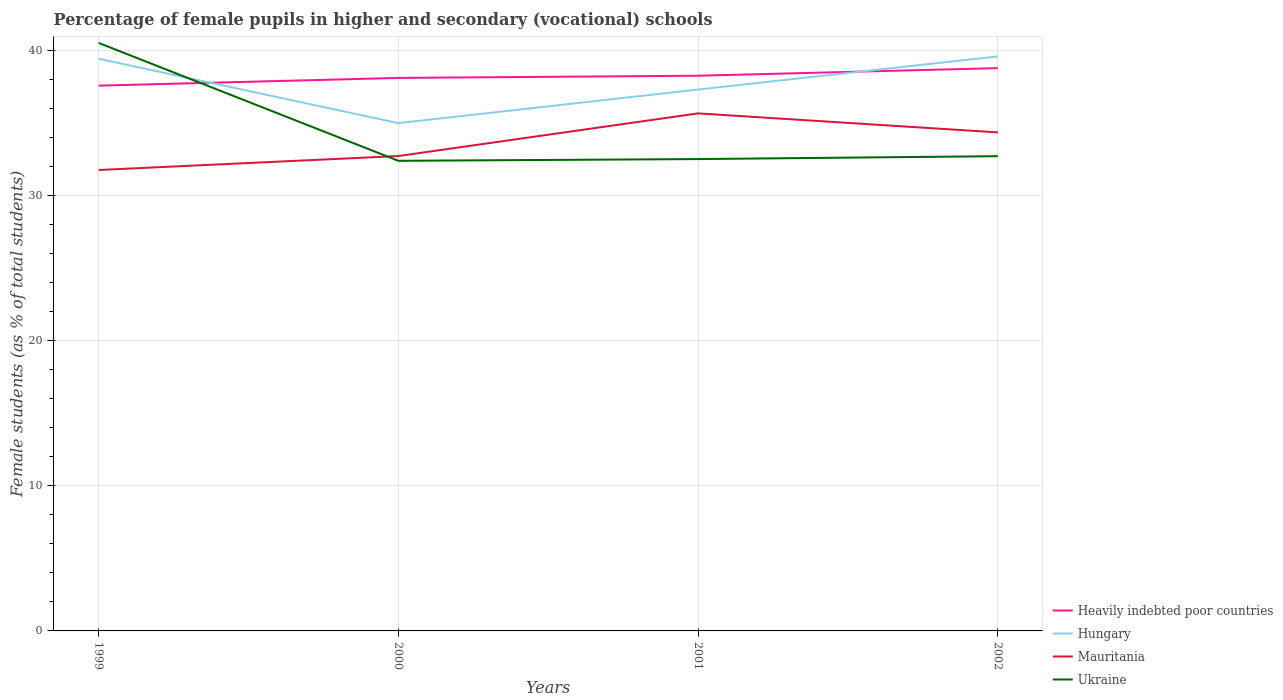How many different coloured lines are there?
Give a very brief answer. 4. Does the line corresponding to Mauritania intersect with the line corresponding to Hungary?
Offer a terse response. No. Across all years, what is the maximum percentage of female pupils in higher and secondary schools in Heavily indebted poor countries?
Make the answer very short. 37.56. What is the total percentage of female pupils in higher and secondary schools in Heavily indebted poor countries in the graph?
Your answer should be compact. -0.15. What is the difference between the highest and the second highest percentage of female pupils in higher and secondary schools in Mauritania?
Make the answer very short. 3.9. What is the difference between two consecutive major ticks on the Y-axis?
Make the answer very short. 10. Are the values on the major ticks of Y-axis written in scientific E-notation?
Your answer should be compact. No. Does the graph contain grids?
Ensure brevity in your answer.  Yes. Where does the legend appear in the graph?
Ensure brevity in your answer.  Bottom right. What is the title of the graph?
Provide a succinct answer. Percentage of female pupils in higher and secondary (vocational) schools. Does "Channel Islands" appear as one of the legend labels in the graph?
Keep it short and to the point. No. What is the label or title of the Y-axis?
Provide a succinct answer. Female students (as % of total students). What is the Female students (as % of total students) in Heavily indebted poor countries in 1999?
Provide a succinct answer. 37.56. What is the Female students (as % of total students) in Hungary in 1999?
Offer a very short reply. 39.41. What is the Female students (as % of total students) of Mauritania in 1999?
Offer a terse response. 31.75. What is the Female students (as % of total students) in Ukraine in 1999?
Your response must be concise. 40.5. What is the Female students (as % of total students) of Heavily indebted poor countries in 2000?
Provide a short and direct response. 38.09. What is the Female students (as % of total students) in Hungary in 2000?
Provide a short and direct response. 34.98. What is the Female students (as % of total students) in Mauritania in 2000?
Ensure brevity in your answer.  32.71. What is the Female students (as % of total students) in Ukraine in 2000?
Offer a terse response. 32.38. What is the Female students (as % of total students) in Heavily indebted poor countries in 2001?
Keep it short and to the point. 38.24. What is the Female students (as % of total students) of Hungary in 2001?
Make the answer very short. 37.29. What is the Female students (as % of total students) of Mauritania in 2001?
Keep it short and to the point. 35.65. What is the Female students (as % of total students) in Ukraine in 2001?
Ensure brevity in your answer.  32.5. What is the Female students (as % of total students) of Heavily indebted poor countries in 2002?
Your answer should be very brief. 38.77. What is the Female students (as % of total students) of Hungary in 2002?
Offer a terse response. 39.57. What is the Female students (as % of total students) of Mauritania in 2002?
Make the answer very short. 34.34. What is the Female students (as % of total students) in Ukraine in 2002?
Keep it short and to the point. 32.7. Across all years, what is the maximum Female students (as % of total students) in Heavily indebted poor countries?
Provide a succinct answer. 38.77. Across all years, what is the maximum Female students (as % of total students) of Hungary?
Your response must be concise. 39.57. Across all years, what is the maximum Female students (as % of total students) in Mauritania?
Offer a terse response. 35.65. Across all years, what is the maximum Female students (as % of total students) of Ukraine?
Your response must be concise. 40.5. Across all years, what is the minimum Female students (as % of total students) of Heavily indebted poor countries?
Your answer should be very brief. 37.56. Across all years, what is the minimum Female students (as % of total students) of Hungary?
Keep it short and to the point. 34.98. Across all years, what is the minimum Female students (as % of total students) of Mauritania?
Offer a terse response. 31.75. Across all years, what is the minimum Female students (as % of total students) of Ukraine?
Provide a short and direct response. 32.38. What is the total Female students (as % of total students) of Heavily indebted poor countries in the graph?
Offer a terse response. 152.65. What is the total Female students (as % of total students) in Hungary in the graph?
Ensure brevity in your answer.  151.25. What is the total Female students (as % of total students) in Mauritania in the graph?
Your answer should be compact. 134.44. What is the total Female students (as % of total students) in Ukraine in the graph?
Keep it short and to the point. 138.08. What is the difference between the Female students (as % of total students) in Heavily indebted poor countries in 1999 and that in 2000?
Provide a short and direct response. -0.53. What is the difference between the Female students (as % of total students) in Hungary in 1999 and that in 2000?
Offer a terse response. 4.43. What is the difference between the Female students (as % of total students) in Mauritania in 1999 and that in 2000?
Provide a succinct answer. -0.96. What is the difference between the Female students (as % of total students) in Ukraine in 1999 and that in 2000?
Give a very brief answer. 8.12. What is the difference between the Female students (as % of total students) of Heavily indebted poor countries in 1999 and that in 2001?
Offer a terse response. -0.68. What is the difference between the Female students (as % of total students) in Hungary in 1999 and that in 2001?
Make the answer very short. 2.12. What is the difference between the Female students (as % of total students) in Mauritania in 1999 and that in 2001?
Provide a short and direct response. -3.9. What is the difference between the Female students (as % of total students) in Ukraine in 1999 and that in 2001?
Provide a succinct answer. 8. What is the difference between the Female students (as % of total students) in Heavily indebted poor countries in 1999 and that in 2002?
Provide a succinct answer. -1.21. What is the difference between the Female students (as % of total students) of Hungary in 1999 and that in 2002?
Make the answer very short. -0.16. What is the difference between the Female students (as % of total students) of Mauritania in 1999 and that in 2002?
Ensure brevity in your answer.  -2.59. What is the difference between the Female students (as % of total students) in Ukraine in 1999 and that in 2002?
Offer a very short reply. 7.8. What is the difference between the Female students (as % of total students) of Heavily indebted poor countries in 2000 and that in 2001?
Give a very brief answer. -0.15. What is the difference between the Female students (as % of total students) of Hungary in 2000 and that in 2001?
Provide a succinct answer. -2.31. What is the difference between the Female students (as % of total students) in Mauritania in 2000 and that in 2001?
Your answer should be very brief. -2.94. What is the difference between the Female students (as % of total students) of Ukraine in 2000 and that in 2001?
Keep it short and to the point. -0.12. What is the difference between the Female students (as % of total students) of Heavily indebted poor countries in 2000 and that in 2002?
Your response must be concise. -0.68. What is the difference between the Female students (as % of total students) in Hungary in 2000 and that in 2002?
Provide a short and direct response. -4.6. What is the difference between the Female students (as % of total students) of Mauritania in 2000 and that in 2002?
Make the answer very short. -1.63. What is the difference between the Female students (as % of total students) in Ukraine in 2000 and that in 2002?
Your answer should be very brief. -0.32. What is the difference between the Female students (as % of total students) of Heavily indebted poor countries in 2001 and that in 2002?
Keep it short and to the point. -0.52. What is the difference between the Female students (as % of total students) of Hungary in 2001 and that in 2002?
Your response must be concise. -2.28. What is the difference between the Female students (as % of total students) in Mauritania in 2001 and that in 2002?
Give a very brief answer. 1.31. What is the difference between the Female students (as % of total students) in Ukraine in 2001 and that in 2002?
Keep it short and to the point. -0.2. What is the difference between the Female students (as % of total students) in Heavily indebted poor countries in 1999 and the Female students (as % of total students) in Hungary in 2000?
Your answer should be compact. 2.58. What is the difference between the Female students (as % of total students) of Heavily indebted poor countries in 1999 and the Female students (as % of total students) of Mauritania in 2000?
Provide a short and direct response. 4.85. What is the difference between the Female students (as % of total students) in Heavily indebted poor countries in 1999 and the Female students (as % of total students) in Ukraine in 2000?
Make the answer very short. 5.18. What is the difference between the Female students (as % of total students) of Hungary in 1999 and the Female students (as % of total students) of Mauritania in 2000?
Provide a succinct answer. 6.7. What is the difference between the Female students (as % of total students) in Hungary in 1999 and the Female students (as % of total students) in Ukraine in 2000?
Offer a terse response. 7.03. What is the difference between the Female students (as % of total students) of Mauritania in 1999 and the Female students (as % of total students) of Ukraine in 2000?
Provide a succinct answer. -0.63. What is the difference between the Female students (as % of total students) in Heavily indebted poor countries in 1999 and the Female students (as % of total students) in Hungary in 2001?
Make the answer very short. 0.27. What is the difference between the Female students (as % of total students) in Heavily indebted poor countries in 1999 and the Female students (as % of total students) in Mauritania in 2001?
Your answer should be very brief. 1.91. What is the difference between the Female students (as % of total students) in Heavily indebted poor countries in 1999 and the Female students (as % of total students) in Ukraine in 2001?
Your answer should be very brief. 5.06. What is the difference between the Female students (as % of total students) in Hungary in 1999 and the Female students (as % of total students) in Mauritania in 2001?
Your answer should be very brief. 3.76. What is the difference between the Female students (as % of total students) in Hungary in 1999 and the Female students (as % of total students) in Ukraine in 2001?
Your response must be concise. 6.91. What is the difference between the Female students (as % of total students) of Mauritania in 1999 and the Female students (as % of total students) of Ukraine in 2001?
Your answer should be compact. -0.75. What is the difference between the Female students (as % of total students) of Heavily indebted poor countries in 1999 and the Female students (as % of total students) of Hungary in 2002?
Make the answer very short. -2.02. What is the difference between the Female students (as % of total students) of Heavily indebted poor countries in 1999 and the Female students (as % of total students) of Mauritania in 2002?
Give a very brief answer. 3.22. What is the difference between the Female students (as % of total students) of Heavily indebted poor countries in 1999 and the Female students (as % of total students) of Ukraine in 2002?
Your response must be concise. 4.86. What is the difference between the Female students (as % of total students) in Hungary in 1999 and the Female students (as % of total students) in Mauritania in 2002?
Keep it short and to the point. 5.07. What is the difference between the Female students (as % of total students) of Hungary in 1999 and the Female students (as % of total students) of Ukraine in 2002?
Make the answer very short. 6.71. What is the difference between the Female students (as % of total students) of Mauritania in 1999 and the Female students (as % of total students) of Ukraine in 2002?
Your response must be concise. -0.95. What is the difference between the Female students (as % of total students) in Heavily indebted poor countries in 2000 and the Female students (as % of total students) in Hungary in 2001?
Ensure brevity in your answer.  0.8. What is the difference between the Female students (as % of total students) of Heavily indebted poor countries in 2000 and the Female students (as % of total students) of Mauritania in 2001?
Offer a terse response. 2.44. What is the difference between the Female students (as % of total students) of Heavily indebted poor countries in 2000 and the Female students (as % of total students) of Ukraine in 2001?
Ensure brevity in your answer.  5.59. What is the difference between the Female students (as % of total students) of Hungary in 2000 and the Female students (as % of total students) of Mauritania in 2001?
Your answer should be compact. -0.67. What is the difference between the Female students (as % of total students) of Hungary in 2000 and the Female students (as % of total students) of Ukraine in 2001?
Your response must be concise. 2.48. What is the difference between the Female students (as % of total students) of Mauritania in 2000 and the Female students (as % of total students) of Ukraine in 2001?
Offer a terse response. 0.21. What is the difference between the Female students (as % of total students) of Heavily indebted poor countries in 2000 and the Female students (as % of total students) of Hungary in 2002?
Offer a very short reply. -1.48. What is the difference between the Female students (as % of total students) in Heavily indebted poor countries in 2000 and the Female students (as % of total students) in Mauritania in 2002?
Make the answer very short. 3.75. What is the difference between the Female students (as % of total students) in Heavily indebted poor countries in 2000 and the Female students (as % of total students) in Ukraine in 2002?
Your response must be concise. 5.39. What is the difference between the Female students (as % of total students) in Hungary in 2000 and the Female students (as % of total students) in Mauritania in 2002?
Your answer should be very brief. 0.64. What is the difference between the Female students (as % of total students) in Hungary in 2000 and the Female students (as % of total students) in Ukraine in 2002?
Provide a succinct answer. 2.28. What is the difference between the Female students (as % of total students) of Mauritania in 2000 and the Female students (as % of total students) of Ukraine in 2002?
Your response must be concise. 0.01. What is the difference between the Female students (as % of total students) in Heavily indebted poor countries in 2001 and the Female students (as % of total students) in Hungary in 2002?
Your answer should be very brief. -1.33. What is the difference between the Female students (as % of total students) of Heavily indebted poor countries in 2001 and the Female students (as % of total students) of Mauritania in 2002?
Offer a very short reply. 3.9. What is the difference between the Female students (as % of total students) in Heavily indebted poor countries in 2001 and the Female students (as % of total students) in Ukraine in 2002?
Provide a succinct answer. 5.54. What is the difference between the Female students (as % of total students) in Hungary in 2001 and the Female students (as % of total students) in Mauritania in 2002?
Provide a succinct answer. 2.95. What is the difference between the Female students (as % of total students) in Hungary in 2001 and the Female students (as % of total students) in Ukraine in 2002?
Give a very brief answer. 4.59. What is the difference between the Female students (as % of total students) of Mauritania in 2001 and the Female students (as % of total students) of Ukraine in 2002?
Give a very brief answer. 2.95. What is the average Female students (as % of total students) in Heavily indebted poor countries per year?
Your answer should be very brief. 38.16. What is the average Female students (as % of total students) of Hungary per year?
Offer a terse response. 37.81. What is the average Female students (as % of total students) in Mauritania per year?
Your answer should be very brief. 33.61. What is the average Female students (as % of total students) in Ukraine per year?
Keep it short and to the point. 34.52. In the year 1999, what is the difference between the Female students (as % of total students) of Heavily indebted poor countries and Female students (as % of total students) of Hungary?
Make the answer very short. -1.85. In the year 1999, what is the difference between the Female students (as % of total students) in Heavily indebted poor countries and Female students (as % of total students) in Mauritania?
Make the answer very short. 5.81. In the year 1999, what is the difference between the Female students (as % of total students) of Heavily indebted poor countries and Female students (as % of total students) of Ukraine?
Offer a terse response. -2.94. In the year 1999, what is the difference between the Female students (as % of total students) of Hungary and Female students (as % of total students) of Mauritania?
Give a very brief answer. 7.66. In the year 1999, what is the difference between the Female students (as % of total students) in Hungary and Female students (as % of total students) in Ukraine?
Provide a succinct answer. -1.09. In the year 1999, what is the difference between the Female students (as % of total students) in Mauritania and Female students (as % of total students) in Ukraine?
Your answer should be very brief. -8.75. In the year 2000, what is the difference between the Female students (as % of total students) of Heavily indebted poor countries and Female students (as % of total students) of Hungary?
Ensure brevity in your answer.  3.11. In the year 2000, what is the difference between the Female students (as % of total students) in Heavily indebted poor countries and Female students (as % of total students) in Mauritania?
Offer a very short reply. 5.38. In the year 2000, what is the difference between the Female students (as % of total students) of Heavily indebted poor countries and Female students (as % of total students) of Ukraine?
Provide a short and direct response. 5.71. In the year 2000, what is the difference between the Female students (as % of total students) in Hungary and Female students (as % of total students) in Mauritania?
Give a very brief answer. 2.27. In the year 2000, what is the difference between the Female students (as % of total students) in Hungary and Female students (as % of total students) in Ukraine?
Your answer should be very brief. 2.6. In the year 2000, what is the difference between the Female students (as % of total students) in Mauritania and Female students (as % of total students) in Ukraine?
Give a very brief answer. 0.33. In the year 2001, what is the difference between the Female students (as % of total students) of Heavily indebted poor countries and Female students (as % of total students) of Hungary?
Your response must be concise. 0.95. In the year 2001, what is the difference between the Female students (as % of total students) in Heavily indebted poor countries and Female students (as % of total students) in Mauritania?
Ensure brevity in your answer.  2.59. In the year 2001, what is the difference between the Female students (as % of total students) of Heavily indebted poor countries and Female students (as % of total students) of Ukraine?
Make the answer very short. 5.74. In the year 2001, what is the difference between the Female students (as % of total students) of Hungary and Female students (as % of total students) of Mauritania?
Your response must be concise. 1.64. In the year 2001, what is the difference between the Female students (as % of total students) of Hungary and Female students (as % of total students) of Ukraine?
Your response must be concise. 4.79. In the year 2001, what is the difference between the Female students (as % of total students) of Mauritania and Female students (as % of total students) of Ukraine?
Make the answer very short. 3.15. In the year 2002, what is the difference between the Female students (as % of total students) in Heavily indebted poor countries and Female students (as % of total students) in Hungary?
Provide a succinct answer. -0.81. In the year 2002, what is the difference between the Female students (as % of total students) of Heavily indebted poor countries and Female students (as % of total students) of Mauritania?
Provide a succinct answer. 4.43. In the year 2002, what is the difference between the Female students (as % of total students) in Heavily indebted poor countries and Female students (as % of total students) in Ukraine?
Your answer should be compact. 6.07. In the year 2002, what is the difference between the Female students (as % of total students) in Hungary and Female students (as % of total students) in Mauritania?
Offer a terse response. 5.24. In the year 2002, what is the difference between the Female students (as % of total students) of Hungary and Female students (as % of total students) of Ukraine?
Provide a short and direct response. 6.87. In the year 2002, what is the difference between the Female students (as % of total students) in Mauritania and Female students (as % of total students) in Ukraine?
Your answer should be very brief. 1.64. What is the ratio of the Female students (as % of total students) of Heavily indebted poor countries in 1999 to that in 2000?
Your response must be concise. 0.99. What is the ratio of the Female students (as % of total students) of Hungary in 1999 to that in 2000?
Your answer should be compact. 1.13. What is the ratio of the Female students (as % of total students) of Mauritania in 1999 to that in 2000?
Your response must be concise. 0.97. What is the ratio of the Female students (as % of total students) in Ukraine in 1999 to that in 2000?
Make the answer very short. 1.25. What is the ratio of the Female students (as % of total students) of Heavily indebted poor countries in 1999 to that in 2001?
Ensure brevity in your answer.  0.98. What is the ratio of the Female students (as % of total students) in Hungary in 1999 to that in 2001?
Make the answer very short. 1.06. What is the ratio of the Female students (as % of total students) in Mauritania in 1999 to that in 2001?
Provide a short and direct response. 0.89. What is the ratio of the Female students (as % of total students) in Ukraine in 1999 to that in 2001?
Offer a very short reply. 1.25. What is the ratio of the Female students (as % of total students) of Heavily indebted poor countries in 1999 to that in 2002?
Make the answer very short. 0.97. What is the ratio of the Female students (as % of total students) of Mauritania in 1999 to that in 2002?
Your response must be concise. 0.92. What is the ratio of the Female students (as % of total students) in Ukraine in 1999 to that in 2002?
Make the answer very short. 1.24. What is the ratio of the Female students (as % of total students) of Hungary in 2000 to that in 2001?
Offer a terse response. 0.94. What is the ratio of the Female students (as % of total students) in Mauritania in 2000 to that in 2001?
Provide a short and direct response. 0.92. What is the ratio of the Female students (as % of total students) of Heavily indebted poor countries in 2000 to that in 2002?
Ensure brevity in your answer.  0.98. What is the ratio of the Female students (as % of total students) of Hungary in 2000 to that in 2002?
Provide a short and direct response. 0.88. What is the ratio of the Female students (as % of total students) in Mauritania in 2000 to that in 2002?
Provide a succinct answer. 0.95. What is the ratio of the Female students (as % of total students) of Ukraine in 2000 to that in 2002?
Offer a terse response. 0.99. What is the ratio of the Female students (as % of total students) of Heavily indebted poor countries in 2001 to that in 2002?
Make the answer very short. 0.99. What is the ratio of the Female students (as % of total students) in Hungary in 2001 to that in 2002?
Give a very brief answer. 0.94. What is the ratio of the Female students (as % of total students) in Mauritania in 2001 to that in 2002?
Provide a succinct answer. 1.04. What is the ratio of the Female students (as % of total students) of Ukraine in 2001 to that in 2002?
Your answer should be compact. 0.99. What is the difference between the highest and the second highest Female students (as % of total students) in Heavily indebted poor countries?
Keep it short and to the point. 0.52. What is the difference between the highest and the second highest Female students (as % of total students) in Hungary?
Offer a very short reply. 0.16. What is the difference between the highest and the second highest Female students (as % of total students) of Mauritania?
Provide a short and direct response. 1.31. What is the difference between the highest and the second highest Female students (as % of total students) in Ukraine?
Your response must be concise. 7.8. What is the difference between the highest and the lowest Female students (as % of total students) of Heavily indebted poor countries?
Ensure brevity in your answer.  1.21. What is the difference between the highest and the lowest Female students (as % of total students) of Hungary?
Give a very brief answer. 4.6. What is the difference between the highest and the lowest Female students (as % of total students) in Mauritania?
Your answer should be compact. 3.9. What is the difference between the highest and the lowest Female students (as % of total students) in Ukraine?
Make the answer very short. 8.12. 